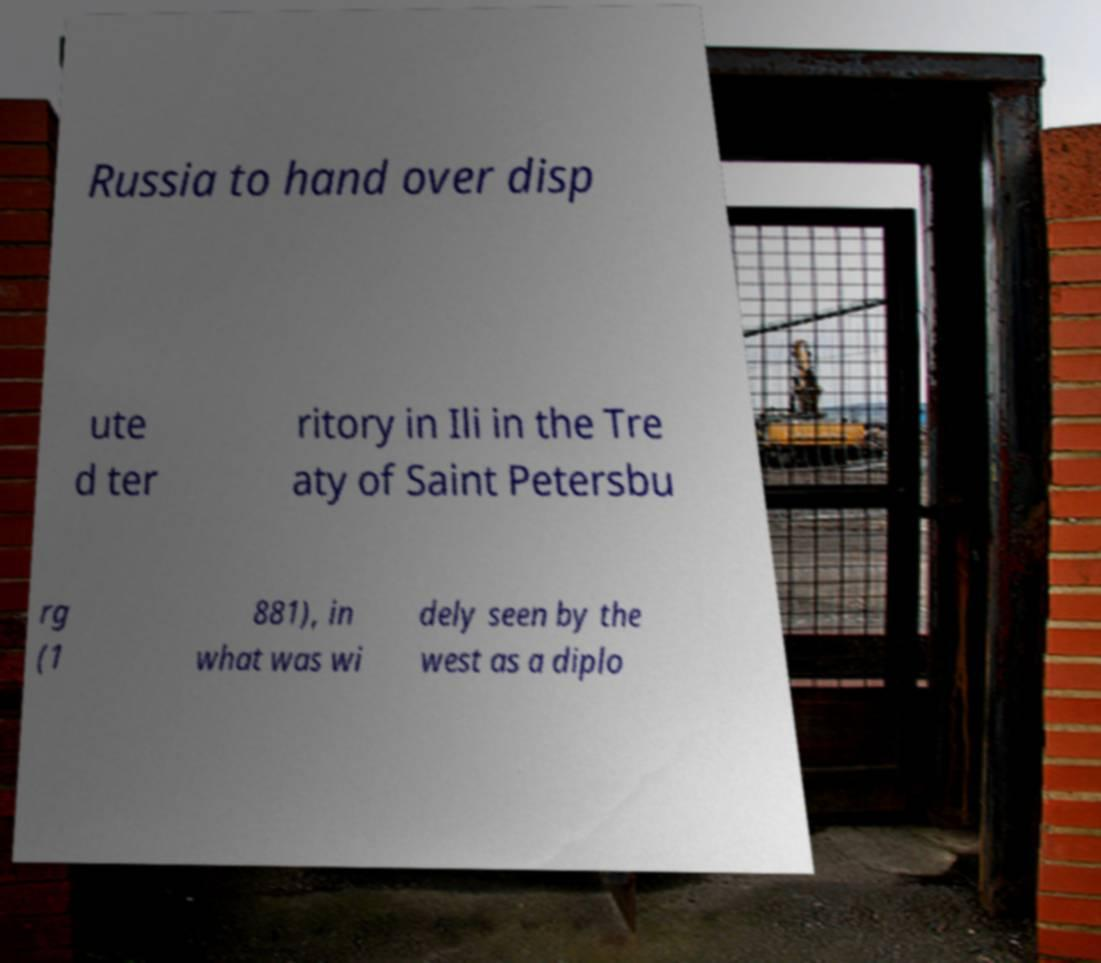Could you assist in decoding the text presented in this image and type it out clearly? Russia to hand over disp ute d ter ritory in Ili in the Tre aty of Saint Petersbu rg (1 881), in what was wi dely seen by the west as a diplo 